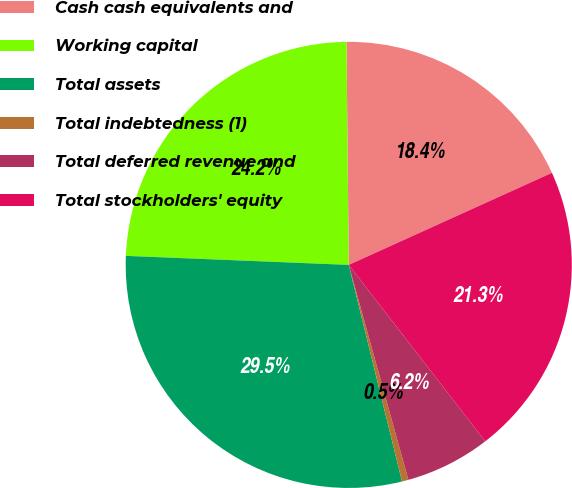Convert chart to OTSL. <chart><loc_0><loc_0><loc_500><loc_500><pie_chart><fcel>Cash cash equivalents and<fcel>Working capital<fcel>Total assets<fcel>Total indebtedness (1)<fcel>Total deferred revenue and<fcel>Total stockholders' equity<nl><fcel>18.39%<fcel>24.19%<fcel>29.48%<fcel>0.47%<fcel>6.17%<fcel>21.29%<nl></chart> 